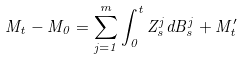<formula> <loc_0><loc_0><loc_500><loc_500>M _ { t } - M _ { 0 } = \sum _ { j = 1 } ^ { m } \int _ { 0 } ^ { t } Z _ { s } ^ { j } d B _ { s } ^ { j } + M _ { t } ^ { \prime }</formula> 